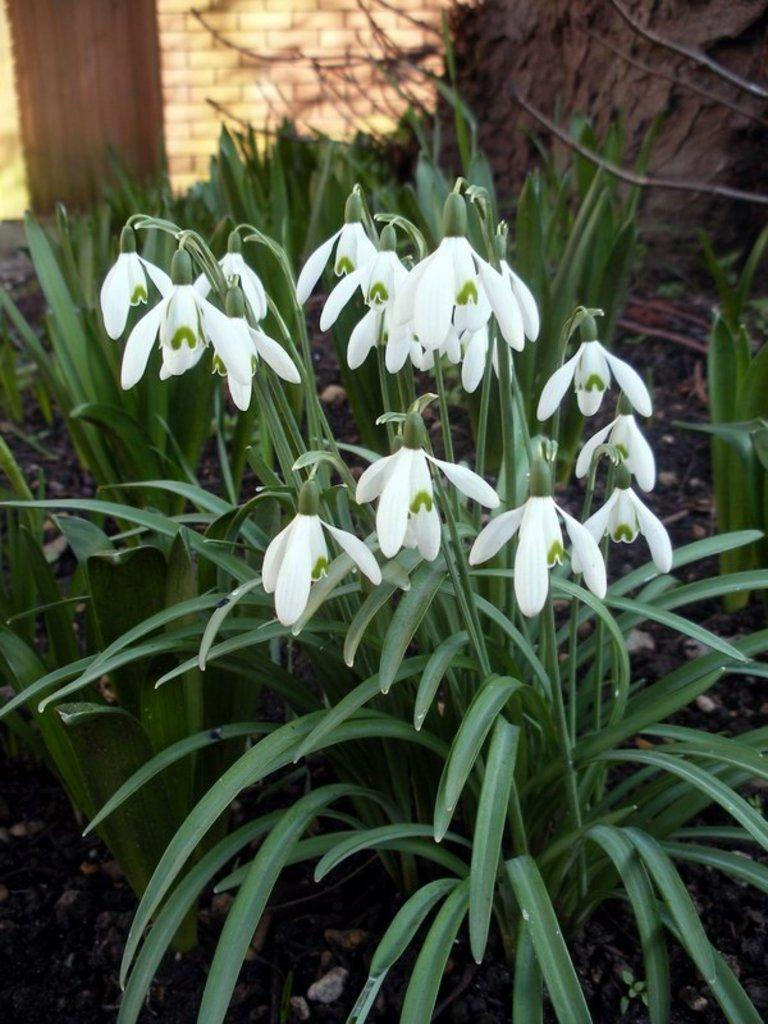What type of living organisms can be seen in the image? Plants can be seen in the image. What color are the flowers on the plants? The flowers on the plants are white. What is the background of the image? There is a wall in the image. How do the giants interact with the plants in the image? There are no giants present in the image, so it is not possible to answer how they might interact with the plants. 